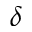<formula> <loc_0><loc_0><loc_500><loc_500>\delta</formula> 